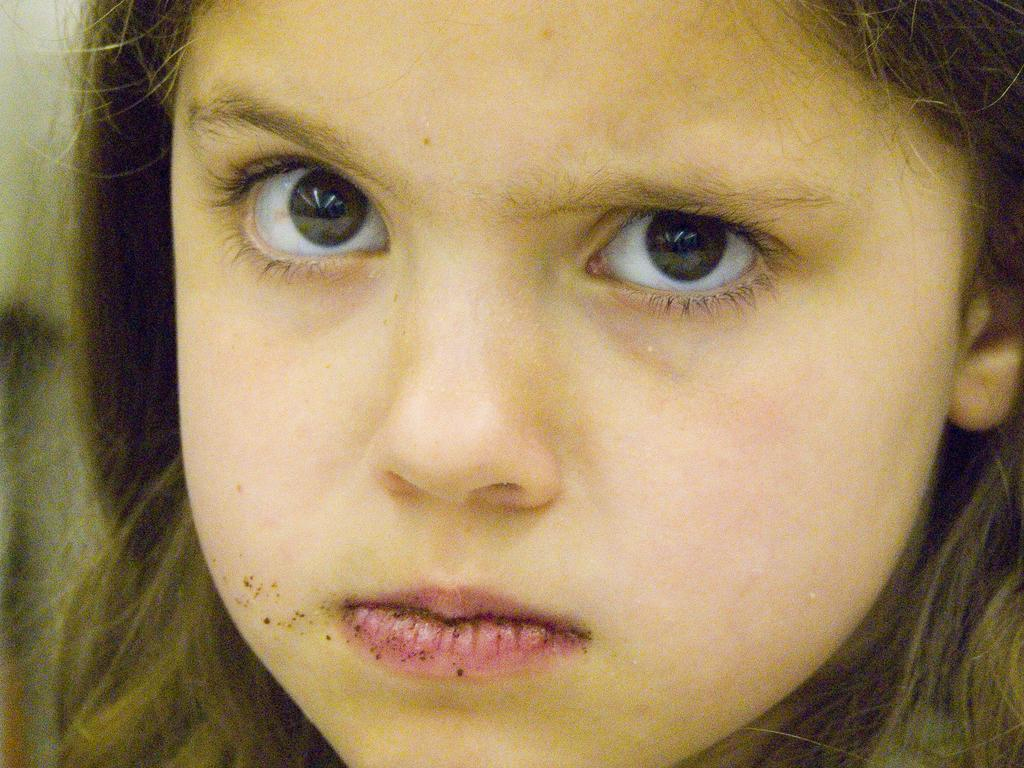Who is the main subject in the image? There is a girl in the image. What is the girl doing in the image? The girl is staring at the camera. What type of destruction can be seen in the image? There is no destruction present in the image; it features a girl staring at the camera. What type of cherry is the girl holding in the image? There is no cherry present in the image. 